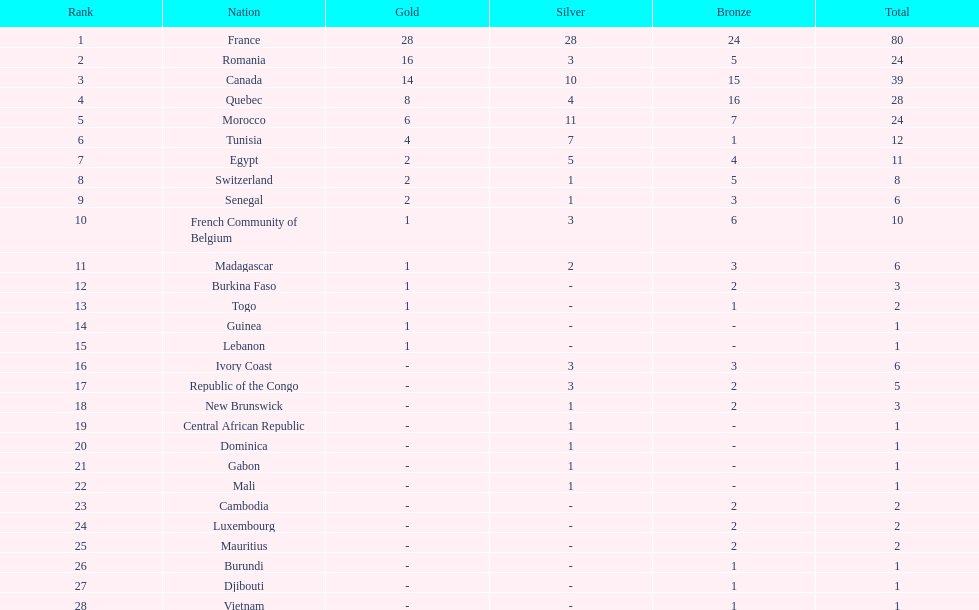How many more medals did egypt win than ivory coast? 5. 